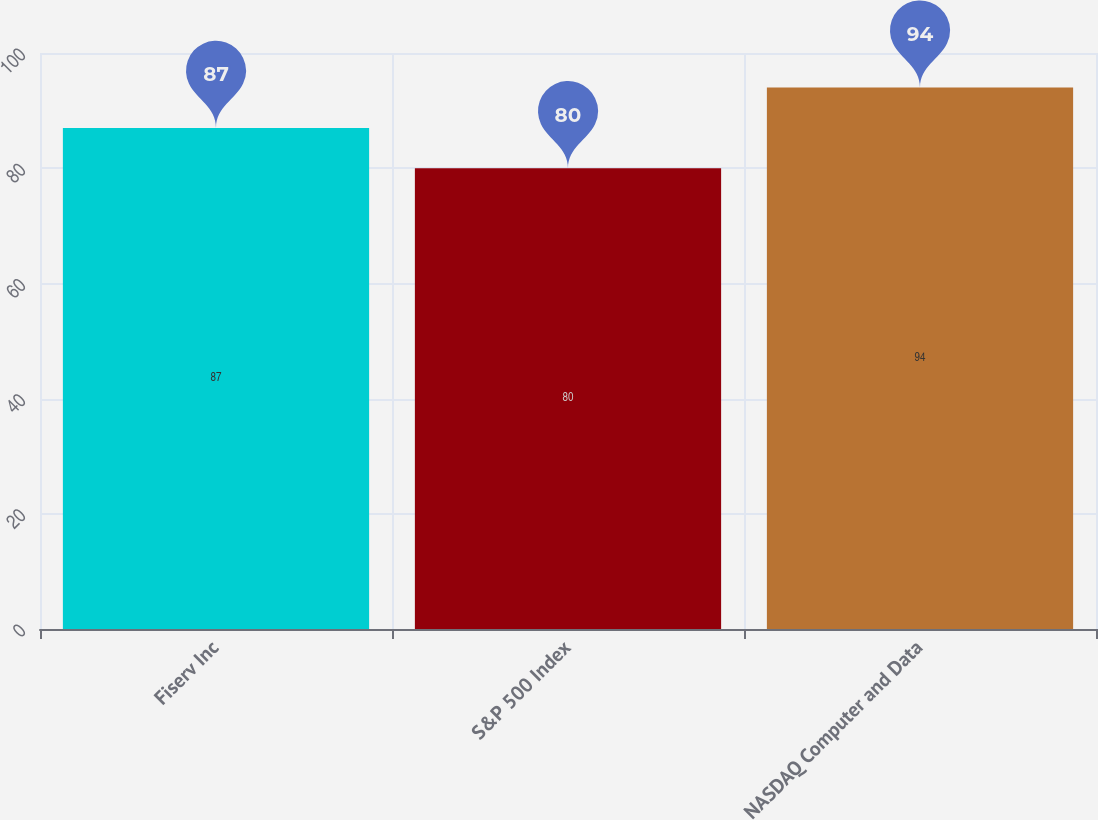Convert chart. <chart><loc_0><loc_0><loc_500><loc_500><bar_chart><fcel>Fiserv Inc<fcel>S&P 500 Index<fcel>NASDAQ Computer and Data<nl><fcel>87<fcel>80<fcel>94<nl></chart> 